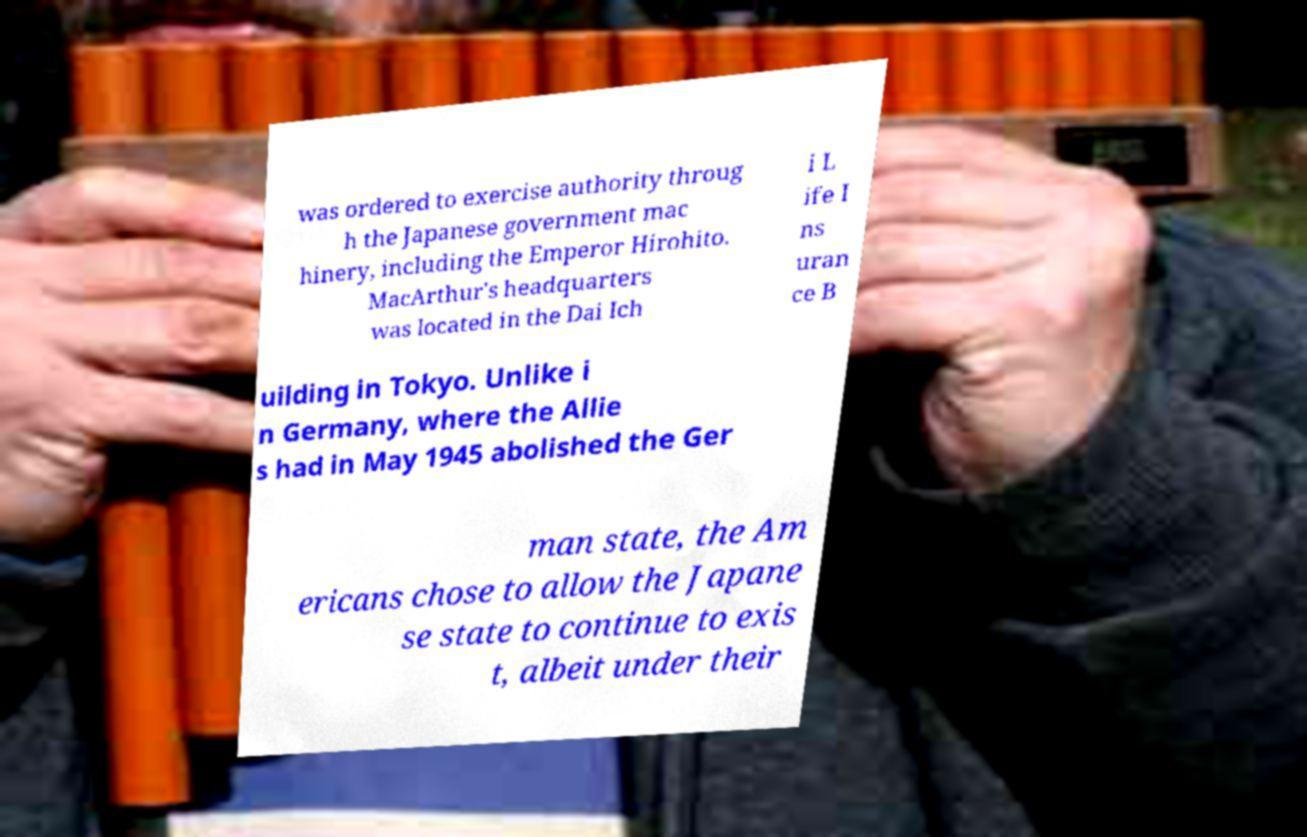There's text embedded in this image that I need extracted. Can you transcribe it verbatim? was ordered to exercise authority throug h the Japanese government mac hinery, including the Emperor Hirohito. MacArthur's headquarters was located in the Dai Ich i L ife I ns uran ce B uilding in Tokyo. Unlike i n Germany, where the Allie s had in May 1945 abolished the Ger man state, the Am ericans chose to allow the Japane se state to continue to exis t, albeit under their 